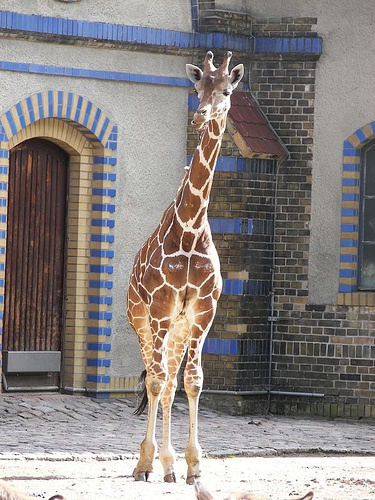Describe the objects in this image and their specific colors. I can see a giraffe in darkgray, ivory, gray, and tan tones in this image. 